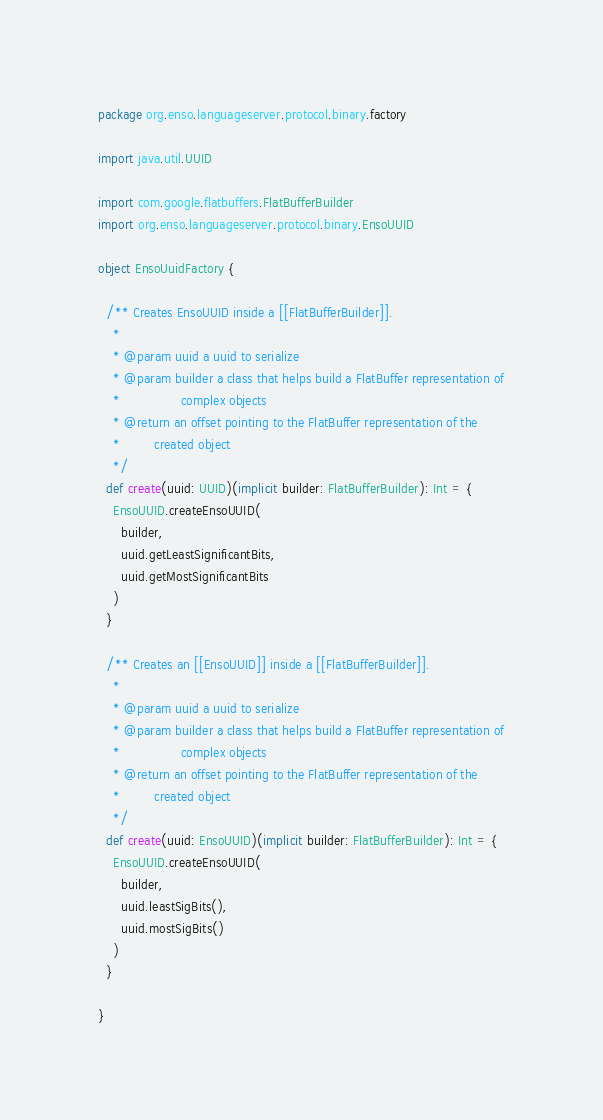<code> <loc_0><loc_0><loc_500><loc_500><_Scala_>package org.enso.languageserver.protocol.binary.factory

import java.util.UUID

import com.google.flatbuffers.FlatBufferBuilder
import org.enso.languageserver.protocol.binary.EnsoUUID

object EnsoUuidFactory {

  /** Creates EnsoUUID inside a [[FlatBufferBuilder]].
    *
    * @param uuid a uuid to serialize
    * @param builder a class that helps build a FlatBuffer representation of
    *                complex objects
    * @return an offset pointing to the FlatBuffer representation of the
    *         created object
    */
  def create(uuid: UUID)(implicit builder: FlatBufferBuilder): Int = {
    EnsoUUID.createEnsoUUID(
      builder,
      uuid.getLeastSignificantBits,
      uuid.getMostSignificantBits
    )
  }

  /** Creates an [[EnsoUUID]] inside a [[FlatBufferBuilder]].
    *
    * @param uuid a uuid to serialize
    * @param builder a class that helps build a FlatBuffer representation of
    *                complex objects
    * @return an offset pointing to the FlatBuffer representation of the
    *         created object
    */
  def create(uuid: EnsoUUID)(implicit builder: FlatBufferBuilder): Int = {
    EnsoUUID.createEnsoUUID(
      builder,
      uuid.leastSigBits(),
      uuid.mostSigBits()
    )
  }

}
</code> 